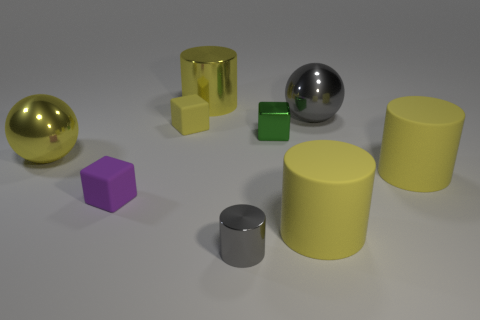Is there a small gray object of the same shape as the tiny yellow matte thing?
Offer a terse response. No. Does the yellow metallic object that is behind the yellow shiny sphere have the same shape as the yellow rubber object that is behind the green thing?
Offer a very short reply. No. There is a yellow matte object that is both behind the tiny purple rubber object and in front of the small yellow block; what is its shape?
Your answer should be very brief. Cylinder. Is there a green object that has the same size as the gray sphere?
Offer a terse response. No. Does the large metal cylinder have the same color as the big thing on the left side of the tiny purple matte object?
Give a very brief answer. Yes. What is the large gray ball made of?
Ensure brevity in your answer.  Metal. There is a metallic sphere behind the large yellow ball; what is its color?
Offer a terse response. Gray. What number of small cubes are the same color as the large shiny cylinder?
Your answer should be very brief. 1. What number of objects are both right of the large metallic cylinder and behind the small yellow cube?
Your answer should be very brief. 1. What shape is the gray object that is the same size as the purple rubber cube?
Provide a short and direct response. Cylinder. 